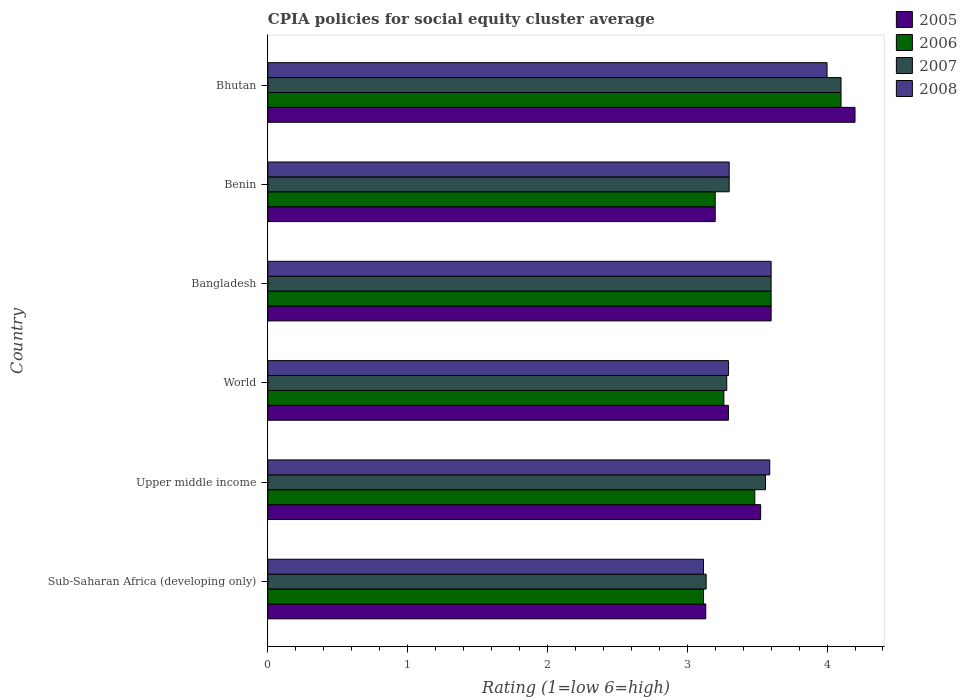How many different coloured bars are there?
Provide a succinct answer. 4. Are the number of bars on each tick of the Y-axis equal?
Offer a terse response. Yes. How many bars are there on the 6th tick from the top?
Your answer should be very brief. 4. What is the label of the 1st group of bars from the top?
Keep it short and to the point. Bhutan. In how many cases, is the number of bars for a given country not equal to the number of legend labels?
Offer a very short reply. 0. What is the CPIA rating in 2008 in Sub-Saharan Africa (developing only)?
Ensure brevity in your answer.  3.12. Across all countries, what is the minimum CPIA rating in 2006?
Provide a succinct answer. 3.12. In which country was the CPIA rating in 2007 maximum?
Offer a very short reply. Bhutan. In which country was the CPIA rating in 2008 minimum?
Provide a short and direct response. Sub-Saharan Africa (developing only). What is the total CPIA rating in 2008 in the graph?
Your response must be concise. 20.9. What is the difference between the CPIA rating in 2008 in Benin and that in Upper middle income?
Your answer should be compact. -0.29. What is the difference between the CPIA rating in 2007 in Bhutan and the CPIA rating in 2008 in Benin?
Your response must be concise. 0.8. What is the average CPIA rating in 2005 per country?
Offer a very short reply. 3.49. In how many countries, is the CPIA rating in 2008 greater than 3 ?
Make the answer very short. 6. What is the ratio of the CPIA rating in 2006 in Sub-Saharan Africa (developing only) to that in World?
Your answer should be very brief. 0.96. What is the difference between the highest and the second highest CPIA rating in 2008?
Your answer should be very brief. 0.4. What is the difference between the highest and the lowest CPIA rating in 2006?
Ensure brevity in your answer.  0.98. In how many countries, is the CPIA rating in 2008 greater than the average CPIA rating in 2008 taken over all countries?
Your response must be concise. 3. What does the 2nd bar from the top in Upper middle income represents?
Offer a terse response. 2007. What does the 2nd bar from the bottom in Sub-Saharan Africa (developing only) represents?
Your answer should be very brief. 2006. Is it the case that in every country, the sum of the CPIA rating in 2006 and CPIA rating in 2008 is greater than the CPIA rating in 2007?
Make the answer very short. Yes. How many bars are there?
Your response must be concise. 24. Are all the bars in the graph horizontal?
Provide a short and direct response. Yes. How many countries are there in the graph?
Your answer should be very brief. 6. Are the values on the major ticks of X-axis written in scientific E-notation?
Make the answer very short. No. Does the graph contain any zero values?
Give a very brief answer. No. Does the graph contain grids?
Your answer should be very brief. No. What is the title of the graph?
Provide a short and direct response. CPIA policies for social equity cluster average. Does "1990" appear as one of the legend labels in the graph?
Provide a succinct answer. No. What is the label or title of the X-axis?
Provide a succinct answer. Rating (1=low 6=high). What is the Rating (1=low 6=high) in 2005 in Sub-Saharan Africa (developing only)?
Provide a succinct answer. 3.13. What is the Rating (1=low 6=high) in 2006 in Sub-Saharan Africa (developing only)?
Keep it short and to the point. 3.12. What is the Rating (1=low 6=high) of 2007 in Sub-Saharan Africa (developing only)?
Offer a very short reply. 3.14. What is the Rating (1=low 6=high) of 2008 in Sub-Saharan Africa (developing only)?
Ensure brevity in your answer.  3.12. What is the Rating (1=low 6=high) in 2005 in Upper middle income?
Offer a very short reply. 3.52. What is the Rating (1=low 6=high) in 2006 in Upper middle income?
Your answer should be very brief. 3.48. What is the Rating (1=low 6=high) of 2007 in Upper middle income?
Offer a very short reply. 3.56. What is the Rating (1=low 6=high) of 2008 in Upper middle income?
Your response must be concise. 3.59. What is the Rating (1=low 6=high) of 2005 in World?
Ensure brevity in your answer.  3.29. What is the Rating (1=low 6=high) of 2006 in World?
Give a very brief answer. 3.26. What is the Rating (1=low 6=high) of 2007 in World?
Provide a short and direct response. 3.28. What is the Rating (1=low 6=high) in 2008 in World?
Offer a terse response. 3.29. What is the Rating (1=low 6=high) in 2005 in Bangladesh?
Your answer should be very brief. 3.6. What is the Rating (1=low 6=high) of 2008 in Bangladesh?
Provide a succinct answer. 3.6. What is the Rating (1=low 6=high) of 2006 in Benin?
Provide a short and direct response. 3.2. What is the Rating (1=low 6=high) of 2007 in Benin?
Keep it short and to the point. 3.3. What is the Rating (1=low 6=high) of 2005 in Bhutan?
Your response must be concise. 4.2. What is the Rating (1=low 6=high) in 2008 in Bhutan?
Make the answer very short. 4. Across all countries, what is the maximum Rating (1=low 6=high) of 2005?
Offer a very short reply. 4.2. Across all countries, what is the maximum Rating (1=low 6=high) in 2007?
Give a very brief answer. 4.1. Across all countries, what is the minimum Rating (1=low 6=high) of 2005?
Offer a very short reply. 3.13. Across all countries, what is the minimum Rating (1=low 6=high) of 2006?
Make the answer very short. 3.12. Across all countries, what is the minimum Rating (1=low 6=high) in 2007?
Your response must be concise. 3.14. Across all countries, what is the minimum Rating (1=low 6=high) of 2008?
Your response must be concise. 3.12. What is the total Rating (1=low 6=high) in 2005 in the graph?
Give a very brief answer. 20.95. What is the total Rating (1=low 6=high) of 2006 in the graph?
Your answer should be compact. 20.76. What is the total Rating (1=low 6=high) in 2007 in the graph?
Your answer should be very brief. 20.98. What is the total Rating (1=low 6=high) of 2008 in the graph?
Your response must be concise. 20.9. What is the difference between the Rating (1=low 6=high) in 2005 in Sub-Saharan Africa (developing only) and that in Upper middle income?
Your answer should be compact. -0.39. What is the difference between the Rating (1=low 6=high) of 2006 in Sub-Saharan Africa (developing only) and that in Upper middle income?
Your answer should be very brief. -0.37. What is the difference between the Rating (1=low 6=high) in 2007 in Sub-Saharan Africa (developing only) and that in Upper middle income?
Keep it short and to the point. -0.42. What is the difference between the Rating (1=low 6=high) in 2008 in Sub-Saharan Africa (developing only) and that in Upper middle income?
Your answer should be compact. -0.47. What is the difference between the Rating (1=low 6=high) in 2005 in Sub-Saharan Africa (developing only) and that in World?
Your answer should be very brief. -0.16. What is the difference between the Rating (1=low 6=high) in 2006 in Sub-Saharan Africa (developing only) and that in World?
Provide a succinct answer. -0.15. What is the difference between the Rating (1=low 6=high) of 2007 in Sub-Saharan Africa (developing only) and that in World?
Give a very brief answer. -0.15. What is the difference between the Rating (1=low 6=high) of 2008 in Sub-Saharan Africa (developing only) and that in World?
Your response must be concise. -0.18. What is the difference between the Rating (1=low 6=high) of 2005 in Sub-Saharan Africa (developing only) and that in Bangladesh?
Offer a very short reply. -0.47. What is the difference between the Rating (1=low 6=high) in 2006 in Sub-Saharan Africa (developing only) and that in Bangladesh?
Make the answer very short. -0.48. What is the difference between the Rating (1=low 6=high) in 2007 in Sub-Saharan Africa (developing only) and that in Bangladesh?
Your response must be concise. -0.46. What is the difference between the Rating (1=low 6=high) of 2008 in Sub-Saharan Africa (developing only) and that in Bangladesh?
Offer a terse response. -0.48. What is the difference between the Rating (1=low 6=high) in 2005 in Sub-Saharan Africa (developing only) and that in Benin?
Offer a terse response. -0.07. What is the difference between the Rating (1=low 6=high) in 2006 in Sub-Saharan Africa (developing only) and that in Benin?
Your answer should be very brief. -0.08. What is the difference between the Rating (1=low 6=high) of 2007 in Sub-Saharan Africa (developing only) and that in Benin?
Your response must be concise. -0.16. What is the difference between the Rating (1=low 6=high) of 2008 in Sub-Saharan Africa (developing only) and that in Benin?
Provide a short and direct response. -0.18. What is the difference between the Rating (1=low 6=high) of 2005 in Sub-Saharan Africa (developing only) and that in Bhutan?
Provide a succinct answer. -1.07. What is the difference between the Rating (1=low 6=high) of 2006 in Sub-Saharan Africa (developing only) and that in Bhutan?
Make the answer very short. -0.98. What is the difference between the Rating (1=low 6=high) in 2007 in Sub-Saharan Africa (developing only) and that in Bhutan?
Your response must be concise. -0.96. What is the difference between the Rating (1=low 6=high) in 2008 in Sub-Saharan Africa (developing only) and that in Bhutan?
Make the answer very short. -0.88. What is the difference between the Rating (1=low 6=high) in 2005 in Upper middle income and that in World?
Give a very brief answer. 0.23. What is the difference between the Rating (1=low 6=high) in 2006 in Upper middle income and that in World?
Make the answer very short. 0.22. What is the difference between the Rating (1=low 6=high) in 2007 in Upper middle income and that in World?
Keep it short and to the point. 0.28. What is the difference between the Rating (1=low 6=high) in 2008 in Upper middle income and that in World?
Your answer should be very brief. 0.3. What is the difference between the Rating (1=low 6=high) in 2005 in Upper middle income and that in Bangladesh?
Ensure brevity in your answer.  -0.07. What is the difference between the Rating (1=low 6=high) of 2006 in Upper middle income and that in Bangladesh?
Give a very brief answer. -0.12. What is the difference between the Rating (1=low 6=high) of 2007 in Upper middle income and that in Bangladesh?
Your answer should be compact. -0.04. What is the difference between the Rating (1=low 6=high) of 2008 in Upper middle income and that in Bangladesh?
Make the answer very short. -0.01. What is the difference between the Rating (1=low 6=high) of 2005 in Upper middle income and that in Benin?
Provide a succinct answer. 0.33. What is the difference between the Rating (1=low 6=high) of 2006 in Upper middle income and that in Benin?
Provide a succinct answer. 0.28. What is the difference between the Rating (1=low 6=high) in 2007 in Upper middle income and that in Benin?
Ensure brevity in your answer.  0.26. What is the difference between the Rating (1=low 6=high) in 2008 in Upper middle income and that in Benin?
Ensure brevity in your answer.  0.29. What is the difference between the Rating (1=low 6=high) in 2005 in Upper middle income and that in Bhutan?
Make the answer very short. -0.68. What is the difference between the Rating (1=low 6=high) in 2006 in Upper middle income and that in Bhutan?
Provide a short and direct response. -0.62. What is the difference between the Rating (1=low 6=high) in 2007 in Upper middle income and that in Bhutan?
Give a very brief answer. -0.54. What is the difference between the Rating (1=low 6=high) in 2008 in Upper middle income and that in Bhutan?
Keep it short and to the point. -0.41. What is the difference between the Rating (1=low 6=high) of 2005 in World and that in Bangladesh?
Offer a terse response. -0.31. What is the difference between the Rating (1=low 6=high) in 2006 in World and that in Bangladesh?
Give a very brief answer. -0.34. What is the difference between the Rating (1=low 6=high) in 2007 in World and that in Bangladesh?
Ensure brevity in your answer.  -0.32. What is the difference between the Rating (1=low 6=high) in 2008 in World and that in Bangladesh?
Your response must be concise. -0.31. What is the difference between the Rating (1=low 6=high) in 2005 in World and that in Benin?
Your answer should be very brief. 0.09. What is the difference between the Rating (1=low 6=high) of 2006 in World and that in Benin?
Ensure brevity in your answer.  0.06. What is the difference between the Rating (1=low 6=high) of 2007 in World and that in Benin?
Offer a terse response. -0.02. What is the difference between the Rating (1=low 6=high) of 2008 in World and that in Benin?
Keep it short and to the point. -0.01. What is the difference between the Rating (1=low 6=high) in 2005 in World and that in Bhutan?
Offer a terse response. -0.91. What is the difference between the Rating (1=low 6=high) of 2006 in World and that in Bhutan?
Your answer should be very brief. -0.84. What is the difference between the Rating (1=low 6=high) in 2007 in World and that in Bhutan?
Your answer should be compact. -0.82. What is the difference between the Rating (1=low 6=high) in 2008 in World and that in Bhutan?
Keep it short and to the point. -0.71. What is the difference between the Rating (1=low 6=high) in 2006 in Bangladesh and that in Benin?
Give a very brief answer. 0.4. What is the difference between the Rating (1=low 6=high) of 2008 in Bangladesh and that in Benin?
Your answer should be very brief. 0.3. What is the difference between the Rating (1=low 6=high) of 2006 in Bangladesh and that in Bhutan?
Your response must be concise. -0.5. What is the difference between the Rating (1=low 6=high) of 2007 in Bangladesh and that in Bhutan?
Your answer should be very brief. -0.5. What is the difference between the Rating (1=low 6=high) of 2008 in Bangladesh and that in Bhutan?
Ensure brevity in your answer.  -0.4. What is the difference between the Rating (1=low 6=high) of 2005 in Benin and that in Bhutan?
Offer a terse response. -1. What is the difference between the Rating (1=low 6=high) in 2005 in Sub-Saharan Africa (developing only) and the Rating (1=low 6=high) in 2006 in Upper middle income?
Offer a very short reply. -0.35. What is the difference between the Rating (1=low 6=high) of 2005 in Sub-Saharan Africa (developing only) and the Rating (1=low 6=high) of 2007 in Upper middle income?
Your answer should be compact. -0.43. What is the difference between the Rating (1=low 6=high) of 2005 in Sub-Saharan Africa (developing only) and the Rating (1=low 6=high) of 2008 in Upper middle income?
Keep it short and to the point. -0.46. What is the difference between the Rating (1=low 6=high) in 2006 in Sub-Saharan Africa (developing only) and the Rating (1=low 6=high) in 2007 in Upper middle income?
Make the answer very short. -0.44. What is the difference between the Rating (1=low 6=high) in 2006 in Sub-Saharan Africa (developing only) and the Rating (1=low 6=high) in 2008 in Upper middle income?
Provide a succinct answer. -0.47. What is the difference between the Rating (1=low 6=high) of 2007 in Sub-Saharan Africa (developing only) and the Rating (1=low 6=high) of 2008 in Upper middle income?
Provide a succinct answer. -0.45. What is the difference between the Rating (1=low 6=high) of 2005 in Sub-Saharan Africa (developing only) and the Rating (1=low 6=high) of 2006 in World?
Provide a succinct answer. -0.13. What is the difference between the Rating (1=low 6=high) of 2005 in Sub-Saharan Africa (developing only) and the Rating (1=low 6=high) of 2008 in World?
Offer a very short reply. -0.16. What is the difference between the Rating (1=low 6=high) of 2006 in Sub-Saharan Africa (developing only) and the Rating (1=low 6=high) of 2007 in World?
Provide a succinct answer. -0.17. What is the difference between the Rating (1=low 6=high) of 2006 in Sub-Saharan Africa (developing only) and the Rating (1=low 6=high) of 2008 in World?
Give a very brief answer. -0.18. What is the difference between the Rating (1=low 6=high) in 2007 in Sub-Saharan Africa (developing only) and the Rating (1=low 6=high) in 2008 in World?
Keep it short and to the point. -0.16. What is the difference between the Rating (1=low 6=high) in 2005 in Sub-Saharan Africa (developing only) and the Rating (1=low 6=high) in 2006 in Bangladesh?
Give a very brief answer. -0.47. What is the difference between the Rating (1=low 6=high) of 2005 in Sub-Saharan Africa (developing only) and the Rating (1=low 6=high) of 2007 in Bangladesh?
Your answer should be compact. -0.47. What is the difference between the Rating (1=low 6=high) in 2005 in Sub-Saharan Africa (developing only) and the Rating (1=low 6=high) in 2008 in Bangladesh?
Provide a succinct answer. -0.47. What is the difference between the Rating (1=low 6=high) in 2006 in Sub-Saharan Africa (developing only) and the Rating (1=low 6=high) in 2007 in Bangladesh?
Give a very brief answer. -0.48. What is the difference between the Rating (1=low 6=high) of 2006 in Sub-Saharan Africa (developing only) and the Rating (1=low 6=high) of 2008 in Bangladesh?
Offer a very short reply. -0.48. What is the difference between the Rating (1=low 6=high) in 2007 in Sub-Saharan Africa (developing only) and the Rating (1=low 6=high) in 2008 in Bangladesh?
Your answer should be very brief. -0.46. What is the difference between the Rating (1=low 6=high) of 2005 in Sub-Saharan Africa (developing only) and the Rating (1=low 6=high) of 2006 in Benin?
Ensure brevity in your answer.  -0.07. What is the difference between the Rating (1=low 6=high) of 2005 in Sub-Saharan Africa (developing only) and the Rating (1=low 6=high) of 2007 in Benin?
Give a very brief answer. -0.17. What is the difference between the Rating (1=low 6=high) in 2005 in Sub-Saharan Africa (developing only) and the Rating (1=low 6=high) in 2008 in Benin?
Provide a succinct answer. -0.17. What is the difference between the Rating (1=low 6=high) in 2006 in Sub-Saharan Africa (developing only) and the Rating (1=low 6=high) in 2007 in Benin?
Provide a succinct answer. -0.18. What is the difference between the Rating (1=low 6=high) in 2006 in Sub-Saharan Africa (developing only) and the Rating (1=low 6=high) in 2008 in Benin?
Your answer should be compact. -0.18. What is the difference between the Rating (1=low 6=high) in 2007 in Sub-Saharan Africa (developing only) and the Rating (1=low 6=high) in 2008 in Benin?
Provide a succinct answer. -0.16. What is the difference between the Rating (1=low 6=high) in 2005 in Sub-Saharan Africa (developing only) and the Rating (1=low 6=high) in 2006 in Bhutan?
Keep it short and to the point. -0.97. What is the difference between the Rating (1=low 6=high) of 2005 in Sub-Saharan Africa (developing only) and the Rating (1=low 6=high) of 2007 in Bhutan?
Make the answer very short. -0.97. What is the difference between the Rating (1=low 6=high) in 2005 in Sub-Saharan Africa (developing only) and the Rating (1=low 6=high) in 2008 in Bhutan?
Offer a very short reply. -0.87. What is the difference between the Rating (1=low 6=high) in 2006 in Sub-Saharan Africa (developing only) and the Rating (1=low 6=high) in 2007 in Bhutan?
Ensure brevity in your answer.  -0.98. What is the difference between the Rating (1=low 6=high) of 2006 in Sub-Saharan Africa (developing only) and the Rating (1=low 6=high) of 2008 in Bhutan?
Provide a short and direct response. -0.88. What is the difference between the Rating (1=low 6=high) in 2007 in Sub-Saharan Africa (developing only) and the Rating (1=low 6=high) in 2008 in Bhutan?
Offer a very short reply. -0.86. What is the difference between the Rating (1=low 6=high) of 2005 in Upper middle income and the Rating (1=low 6=high) of 2006 in World?
Give a very brief answer. 0.26. What is the difference between the Rating (1=low 6=high) in 2005 in Upper middle income and the Rating (1=low 6=high) in 2007 in World?
Your response must be concise. 0.24. What is the difference between the Rating (1=low 6=high) of 2005 in Upper middle income and the Rating (1=low 6=high) of 2008 in World?
Keep it short and to the point. 0.23. What is the difference between the Rating (1=low 6=high) of 2006 in Upper middle income and the Rating (1=low 6=high) of 2007 in World?
Ensure brevity in your answer.  0.2. What is the difference between the Rating (1=low 6=high) in 2006 in Upper middle income and the Rating (1=low 6=high) in 2008 in World?
Your response must be concise. 0.19. What is the difference between the Rating (1=low 6=high) in 2007 in Upper middle income and the Rating (1=low 6=high) in 2008 in World?
Offer a very short reply. 0.27. What is the difference between the Rating (1=low 6=high) in 2005 in Upper middle income and the Rating (1=low 6=high) in 2006 in Bangladesh?
Provide a short and direct response. -0.07. What is the difference between the Rating (1=low 6=high) in 2005 in Upper middle income and the Rating (1=low 6=high) in 2007 in Bangladesh?
Keep it short and to the point. -0.07. What is the difference between the Rating (1=low 6=high) of 2005 in Upper middle income and the Rating (1=low 6=high) of 2008 in Bangladesh?
Ensure brevity in your answer.  -0.07. What is the difference between the Rating (1=low 6=high) in 2006 in Upper middle income and the Rating (1=low 6=high) in 2007 in Bangladesh?
Provide a short and direct response. -0.12. What is the difference between the Rating (1=low 6=high) in 2006 in Upper middle income and the Rating (1=low 6=high) in 2008 in Bangladesh?
Provide a succinct answer. -0.12. What is the difference between the Rating (1=low 6=high) of 2007 in Upper middle income and the Rating (1=low 6=high) of 2008 in Bangladesh?
Provide a short and direct response. -0.04. What is the difference between the Rating (1=low 6=high) in 2005 in Upper middle income and the Rating (1=low 6=high) in 2006 in Benin?
Ensure brevity in your answer.  0.33. What is the difference between the Rating (1=low 6=high) in 2005 in Upper middle income and the Rating (1=low 6=high) in 2007 in Benin?
Keep it short and to the point. 0.23. What is the difference between the Rating (1=low 6=high) in 2005 in Upper middle income and the Rating (1=low 6=high) in 2008 in Benin?
Your answer should be very brief. 0.23. What is the difference between the Rating (1=low 6=high) of 2006 in Upper middle income and the Rating (1=low 6=high) of 2007 in Benin?
Ensure brevity in your answer.  0.18. What is the difference between the Rating (1=low 6=high) in 2006 in Upper middle income and the Rating (1=low 6=high) in 2008 in Benin?
Ensure brevity in your answer.  0.18. What is the difference between the Rating (1=low 6=high) of 2007 in Upper middle income and the Rating (1=low 6=high) of 2008 in Benin?
Ensure brevity in your answer.  0.26. What is the difference between the Rating (1=low 6=high) of 2005 in Upper middle income and the Rating (1=low 6=high) of 2006 in Bhutan?
Your answer should be very brief. -0.57. What is the difference between the Rating (1=low 6=high) of 2005 in Upper middle income and the Rating (1=low 6=high) of 2007 in Bhutan?
Provide a succinct answer. -0.57. What is the difference between the Rating (1=low 6=high) in 2005 in Upper middle income and the Rating (1=low 6=high) in 2008 in Bhutan?
Give a very brief answer. -0.47. What is the difference between the Rating (1=low 6=high) of 2006 in Upper middle income and the Rating (1=low 6=high) of 2007 in Bhutan?
Your answer should be compact. -0.62. What is the difference between the Rating (1=low 6=high) of 2006 in Upper middle income and the Rating (1=low 6=high) of 2008 in Bhutan?
Provide a short and direct response. -0.52. What is the difference between the Rating (1=low 6=high) in 2007 in Upper middle income and the Rating (1=low 6=high) in 2008 in Bhutan?
Your response must be concise. -0.44. What is the difference between the Rating (1=low 6=high) of 2005 in World and the Rating (1=low 6=high) of 2006 in Bangladesh?
Ensure brevity in your answer.  -0.31. What is the difference between the Rating (1=low 6=high) in 2005 in World and the Rating (1=low 6=high) in 2007 in Bangladesh?
Ensure brevity in your answer.  -0.31. What is the difference between the Rating (1=low 6=high) in 2005 in World and the Rating (1=low 6=high) in 2008 in Bangladesh?
Provide a short and direct response. -0.31. What is the difference between the Rating (1=low 6=high) in 2006 in World and the Rating (1=low 6=high) in 2007 in Bangladesh?
Ensure brevity in your answer.  -0.34. What is the difference between the Rating (1=low 6=high) in 2006 in World and the Rating (1=low 6=high) in 2008 in Bangladesh?
Ensure brevity in your answer.  -0.34. What is the difference between the Rating (1=low 6=high) in 2007 in World and the Rating (1=low 6=high) in 2008 in Bangladesh?
Provide a succinct answer. -0.32. What is the difference between the Rating (1=low 6=high) in 2005 in World and the Rating (1=low 6=high) in 2006 in Benin?
Keep it short and to the point. 0.09. What is the difference between the Rating (1=low 6=high) in 2005 in World and the Rating (1=low 6=high) in 2007 in Benin?
Offer a terse response. -0.01. What is the difference between the Rating (1=low 6=high) of 2005 in World and the Rating (1=low 6=high) of 2008 in Benin?
Your answer should be very brief. -0.01. What is the difference between the Rating (1=low 6=high) of 2006 in World and the Rating (1=low 6=high) of 2007 in Benin?
Your response must be concise. -0.04. What is the difference between the Rating (1=low 6=high) of 2006 in World and the Rating (1=low 6=high) of 2008 in Benin?
Your answer should be compact. -0.04. What is the difference between the Rating (1=low 6=high) in 2007 in World and the Rating (1=low 6=high) in 2008 in Benin?
Your answer should be compact. -0.02. What is the difference between the Rating (1=low 6=high) of 2005 in World and the Rating (1=low 6=high) of 2006 in Bhutan?
Provide a succinct answer. -0.81. What is the difference between the Rating (1=low 6=high) of 2005 in World and the Rating (1=low 6=high) of 2007 in Bhutan?
Offer a very short reply. -0.81. What is the difference between the Rating (1=low 6=high) of 2005 in World and the Rating (1=low 6=high) of 2008 in Bhutan?
Offer a very short reply. -0.71. What is the difference between the Rating (1=low 6=high) of 2006 in World and the Rating (1=low 6=high) of 2007 in Bhutan?
Ensure brevity in your answer.  -0.84. What is the difference between the Rating (1=low 6=high) in 2006 in World and the Rating (1=low 6=high) in 2008 in Bhutan?
Provide a short and direct response. -0.74. What is the difference between the Rating (1=low 6=high) in 2007 in World and the Rating (1=low 6=high) in 2008 in Bhutan?
Give a very brief answer. -0.72. What is the difference between the Rating (1=low 6=high) in 2005 in Bangladesh and the Rating (1=low 6=high) in 2007 in Benin?
Keep it short and to the point. 0.3. What is the difference between the Rating (1=low 6=high) in 2005 in Bangladesh and the Rating (1=low 6=high) in 2008 in Benin?
Offer a very short reply. 0.3. What is the difference between the Rating (1=low 6=high) of 2006 in Bangladesh and the Rating (1=low 6=high) of 2008 in Benin?
Offer a terse response. 0.3. What is the difference between the Rating (1=low 6=high) in 2007 in Bangladesh and the Rating (1=low 6=high) in 2008 in Benin?
Offer a very short reply. 0.3. What is the difference between the Rating (1=low 6=high) in 2005 in Bangladesh and the Rating (1=low 6=high) in 2007 in Bhutan?
Make the answer very short. -0.5. What is the difference between the Rating (1=low 6=high) of 2006 in Bangladesh and the Rating (1=low 6=high) of 2007 in Bhutan?
Your answer should be compact. -0.5. What is the difference between the Rating (1=low 6=high) in 2006 in Bangladesh and the Rating (1=low 6=high) in 2008 in Bhutan?
Give a very brief answer. -0.4. What is the difference between the Rating (1=low 6=high) of 2007 in Bangladesh and the Rating (1=low 6=high) of 2008 in Bhutan?
Ensure brevity in your answer.  -0.4. What is the difference between the Rating (1=low 6=high) in 2005 in Benin and the Rating (1=low 6=high) in 2006 in Bhutan?
Keep it short and to the point. -0.9. What is the difference between the Rating (1=low 6=high) of 2005 in Benin and the Rating (1=low 6=high) of 2008 in Bhutan?
Provide a short and direct response. -0.8. What is the difference between the Rating (1=low 6=high) in 2006 in Benin and the Rating (1=low 6=high) in 2008 in Bhutan?
Provide a short and direct response. -0.8. What is the difference between the Rating (1=low 6=high) in 2007 in Benin and the Rating (1=low 6=high) in 2008 in Bhutan?
Make the answer very short. -0.7. What is the average Rating (1=low 6=high) of 2005 per country?
Your response must be concise. 3.49. What is the average Rating (1=low 6=high) in 2006 per country?
Keep it short and to the point. 3.46. What is the average Rating (1=low 6=high) of 2007 per country?
Make the answer very short. 3.5. What is the average Rating (1=low 6=high) of 2008 per country?
Your answer should be very brief. 3.48. What is the difference between the Rating (1=low 6=high) in 2005 and Rating (1=low 6=high) in 2006 in Sub-Saharan Africa (developing only)?
Your answer should be compact. 0.02. What is the difference between the Rating (1=low 6=high) in 2005 and Rating (1=low 6=high) in 2007 in Sub-Saharan Africa (developing only)?
Ensure brevity in your answer.  -0. What is the difference between the Rating (1=low 6=high) in 2005 and Rating (1=low 6=high) in 2008 in Sub-Saharan Africa (developing only)?
Provide a short and direct response. 0.02. What is the difference between the Rating (1=low 6=high) in 2006 and Rating (1=low 6=high) in 2007 in Sub-Saharan Africa (developing only)?
Offer a very short reply. -0.02. What is the difference between the Rating (1=low 6=high) of 2007 and Rating (1=low 6=high) of 2008 in Sub-Saharan Africa (developing only)?
Offer a terse response. 0.02. What is the difference between the Rating (1=low 6=high) in 2005 and Rating (1=low 6=high) in 2006 in Upper middle income?
Provide a short and direct response. 0.04. What is the difference between the Rating (1=low 6=high) of 2005 and Rating (1=low 6=high) of 2007 in Upper middle income?
Provide a succinct answer. -0.04. What is the difference between the Rating (1=low 6=high) of 2005 and Rating (1=low 6=high) of 2008 in Upper middle income?
Provide a short and direct response. -0.07. What is the difference between the Rating (1=low 6=high) in 2006 and Rating (1=low 6=high) in 2007 in Upper middle income?
Your answer should be compact. -0.08. What is the difference between the Rating (1=low 6=high) of 2006 and Rating (1=low 6=high) of 2008 in Upper middle income?
Provide a succinct answer. -0.11. What is the difference between the Rating (1=low 6=high) in 2007 and Rating (1=low 6=high) in 2008 in Upper middle income?
Your answer should be compact. -0.03. What is the difference between the Rating (1=low 6=high) of 2005 and Rating (1=low 6=high) of 2006 in World?
Offer a terse response. 0.03. What is the difference between the Rating (1=low 6=high) of 2005 and Rating (1=low 6=high) of 2007 in World?
Offer a terse response. 0.01. What is the difference between the Rating (1=low 6=high) in 2005 and Rating (1=low 6=high) in 2008 in World?
Your response must be concise. -0. What is the difference between the Rating (1=low 6=high) of 2006 and Rating (1=low 6=high) of 2007 in World?
Provide a short and direct response. -0.02. What is the difference between the Rating (1=low 6=high) in 2006 and Rating (1=low 6=high) in 2008 in World?
Give a very brief answer. -0.03. What is the difference between the Rating (1=low 6=high) of 2007 and Rating (1=low 6=high) of 2008 in World?
Provide a succinct answer. -0.01. What is the difference between the Rating (1=low 6=high) of 2005 and Rating (1=low 6=high) of 2006 in Bangladesh?
Your answer should be very brief. 0. What is the difference between the Rating (1=low 6=high) of 2005 and Rating (1=low 6=high) of 2008 in Bangladesh?
Provide a succinct answer. 0. What is the difference between the Rating (1=low 6=high) in 2006 and Rating (1=low 6=high) in 2007 in Bangladesh?
Your response must be concise. 0. What is the difference between the Rating (1=low 6=high) of 2006 and Rating (1=low 6=high) of 2008 in Bangladesh?
Offer a very short reply. 0. What is the difference between the Rating (1=low 6=high) of 2005 and Rating (1=low 6=high) of 2006 in Benin?
Keep it short and to the point. 0. What is the difference between the Rating (1=low 6=high) of 2005 and Rating (1=low 6=high) of 2008 in Benin?
Provide a short and direct response. -0.1. What is the difference between the Rating (1=low 6=high) in 2006 and Rating (1=low 6=high) in 2008 in Benin?
Your answer should be very brief. -0.1. What is the difference between the Rating (1=low 6=high) in 2006 and Rating (1=low 6=high) in 2008 in Bhutan?
Your answer should be compact. 0.1. What is the difference between the Rating (1=low 6=high) of 2007 and Rating (1=low 6=high) of 2008 in Bhutan?
Your answer should be compact. 0.1. What is the ratio of the Rating (1=low 6=high) of 2005 in Sub-Saharan Africa (developing only) to that in Upper middle income?
Provide a short and direct response. 0.89. What is the ratio of the Rating (1=low 6=high) in 2006 in Sub-Saharan Africa (developing only) to that in Upper middle income?
Give a very brief answer. 0.89. What is the ratio of the Rating (1=low 6=high) in 2007 in Sub-Saharan Africa (developing only) to that in Upper middle income?
Your answer should be compact. 0.88. What is the ratio of the Rating (1=low 6=high) of 2008 in Sub-Saharan Africa (developing only) to that in Upper middle income?
Offer a very short reply. 0.87. What is the ratio of the Rating (1=low 6=high) of 2005 in Sub-Saharan Africa (developing only) to that in World?
Your response must be concise. 0.95. What is the ratio of the Rating (1=low 6=high) of 2006 in Sub-Saharan Africa (developing only) to that in World?
Keep it short and to the point. 0.96. What is the ratio of the Rating (1=low 6=high) of 2007 in Sub-Saharan Africa (developing only) to that in World?
Give a very brief answer. 0.96. What is the ratio of the Rating (1=low 6=high) in 2008 in Sub-Saharan Africa (developing only) to that in World?
Your answer should be compact. 0.95. What is the ratio of the Rating (1=low 6=high) of 2005 in Sub-Saharan Africa (developing only) to that in Bangladesh?
Your answer should be compact. 0.87. What is the ratio of the Rating (1=low 6=high) in 2006 in Sub-Saharan Africa (developing only) to that in Bangladesh?
Your answer should be very brief. 0.87. What is the ratio of the Rating (1=low 6=high) in 2007 in Sub-Saharan Africa (developing only) to that in Bangladesh?
Offer a very short reply. 0.87. What is the ratio of the Rating (1=low 6=high) of 2008 in Sub-Saharan Africa (developing only) to that in Bangladesh?
Make the answer very short. 0.87. What is the ratio of the Rating (1=low 6=high) in 2005 in Sub-Saharan Africa (developing only) to that in Benin?
Offer a very short reply. 0.98. What is the ratio of the Rating (1=low 6=high) in 2006 in Sub-Saharan Africa (developing only) to that in Benin?
Your response must be concise. 0.97. What is the ratio of the Rating (1=low 6=high) of 2007 in Sub-Saharan Africa (developing only) to that in Benin?
Offer a very short reply. 0.95. What is the ratio of the Rating (1=low 6=high) of 2008 in Sub-Saharan Africa (developing only) to that in Benin?
Offer a very short reply. 0.94. What is the ratio of the Rating (1=low 6=high) of 2005 in Sub-Saharan Africa (developing only) to that in Bhutan?
Offer a very short reply. 0.75. What is the ratio of the Rating (1=low 6=high) of 2006 in Sub-Saharan Africa (developing only) to that in Bhutan?
Your response must be concise. 0.76. What is the ratio of the Rating (1=low 6=high) of 2007 in Sub-Saharan Africa (developing only) to that in Bhutan?
Ensure brevity in your answer.  0.76. What is the ratio of the Rating (1=low 6=high) of 2008 in Sub-Saharan Africa (developing only) to that in Bhutan?
Offer a terse response. 0.78. What is the ratio of the Rating (1=low 6=high) of 2005 in Upper middle income to that in World?
Offer a very short reply. 1.07. What is the ratio of the Rating (1=low 6=high) in 2006 in Upper middle income to that in World?
Your response must be concise. 1.07. What is the ratio of the Rating (1=low 6=high) in 2007 in Upper middle income to that in World?
Provide a short and direct response. 1.08. What is the ratio of the Rating (1=low 6=high) in 2008 in Upper middle income to that in World?
Offer a very short reply. 1.09. What is the ratio of the Rating (1=low 6=high) of 2005 in Upper middle income to that in Bangladesh?
Keep it short and to the point. 0.98. What is the ratio of the Rating (1=low 6=high) in 2006 in Upper middle income to that in Bangladesh?
Provide a short and direct response. 0.97. What is the ratio of the Rating (1=low 6=high) of 2007 in Upper middle income to that in Bangladesh?
Your answer should be very brief. 0.99. What is the ratio of the Rating (1=low 6=high) of 2005 in Upper middle income to that in Benin?
Offer a very short reply. 1.1. What is the ratio of the Rating (1=low 6=high) in 2006 in Upper middle income to that in Benin?
Keep it short and to the point. 1.09. What is the ratio of the Rating (1=low 6=high) in 2007 in Upper middle income to that in Benin?
Provide a succinct answer. 1.08. What is the ratio of the Rating (1=low 6=high) of 2008 in Upper middle income to that in Benin?
Keep it short and to the point. 1.09. What is the ratio of the Rating (1=low 6=high) in 2005 in Upper middle income to that in Bhutan?
Your answer should be compact. 0.84. What is the ratio of the Rating (1=low 6=high) of 2006 in Upper middle income to that in Bhutan?
Make the answer very short. 0.85. What is the ratio of the Rating (1=low 6=high) of 2007 in Upper middle income to that in Bhutan?
Your answer should be very brief. 0.87. What is the ratio of the Rating (1=low 6=high) of 2008 in Upper middle income to that in Bhutan?
Keep it short and to the point. 0.9. What is the ratio of the Rating (1=low 6=high) of 2005 in World to that in Bangladesh?
Offer a terse response. 0.92. What is the ratio of the Rating (1=low 6=high) in 2006 in World to that in Bangladesh?
Make the answer very short. 0.91. What is the ratio of the Rating (1=low 6=high) of 2007 in World to that in Bangladesh?
Provide a succinct answer. 0.91. What is the ratio of the Rating (1=low 6=high) in 2008 in World to that in Bangladesh?
Ensure brevity in your answer.  0.92. What is the ratio of the Rating (1=low 6=high) of 2005 in World to that in Benin?
Provide a succinct answer. 1.03. What is the ratio of the Rating (1=low 6=high) in 2006 in World to that in Benin?
Your answer should be very brief. 1.02. What is the ratio of the Rating (1=low 6=high) of 2005 in World to that in Bhutan?
Your response must be concise. 0.78. What is the ratio of the Rating (1=low 6=high) of 2006 in World to that in Bhutan?
Offer a terse response. 0.8. What is the ratio of the Rating (1=low 6=high) in 2007 in World to that in Bhutan?
Provide a succinct answer. 0.8. What is the ratio of the Rating (1=low 6=high) in 2008 in World to that in Bhutan?
Ensure brevity in your answer.  0.82. What is the ratio of the Rating (1=low 6=high) of 2005 in Bangladesh to that in Bhutan?
Ensure brevity in your answer.  0.86. What is the ratio of the Rating (1=low 6=high) of 2006 in Bangladesh to that in Bhutan?
Ensure brevity in your answer.  0.88. What is the ratio of the Rating (1=low 6=high) in 2007 in Bangladesh to that in Bhutan?
Ensure brevity in your answer.  0.88. What is the ratio of the Rating (1=low 6=high) of 2005 in Benin to that in Bhutan?
Make the answer very short. 0.76. What is the ratio of the Rating (1=low 6=high) in 2006 in Benin to that in Bhutan?
Ensure brevity in your answer.  0.78. What is the ratio of the Rating (1=low 6=high) of 2007 in Benin to that in Bhutan?
Your response must be concise. 0.8. What is the ratio of the Rating (1=low 6=high) in 2008 in Benin to that in Bhutan?
Keep it short and to the point. 0.82. What is the difference between the highest and the second highest Rating (1=low 6=high) in 2006?
Provide a succinct answer. 0.5. What is the difference between the highest and the lowest Rating (1=low 6=high) in 2005?
Provide a short and direct response. 1.07. What is the difference between the highest and the lowest Rating (1=low 6=high) in 2006?
Provide a short and direct response. 0.98. What is the difference between the highest and the lowest Rating (1=low 6=high) of 2007?
Offer a terse response. 0.96. What is the difference between the highest and the lowest Rating (1=low 6=high) in 2008?
Offer a very short reply. 0.88. 